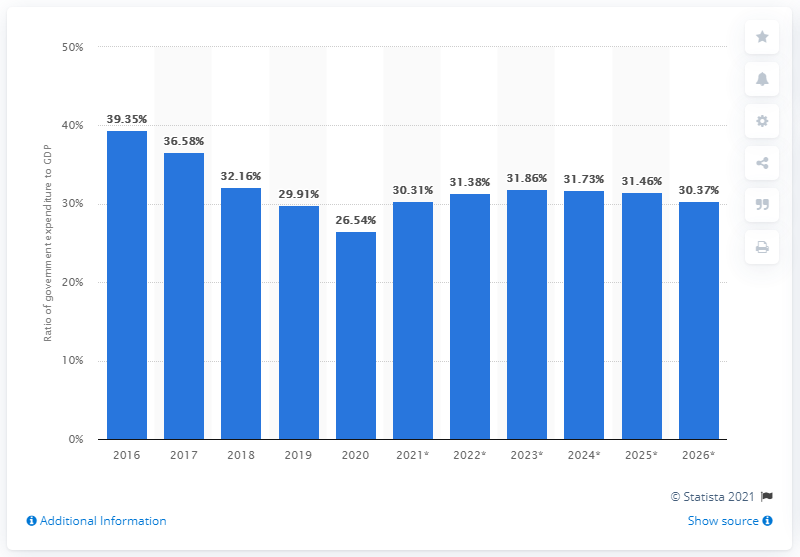Highlight a few significant elements in this photo. In 2020, approximately 26.54% of Brunei Darussalam's Gross Domestic Product (GDP) was spent. 